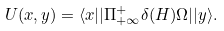<formula> <loc_0><loc_0><loc_500><loc_500>U ( x , y ) = \langle x | | \Pi ^ { + } _ { + \infty } \delta ( H ) \Omega | | y \rangle .</formula> 